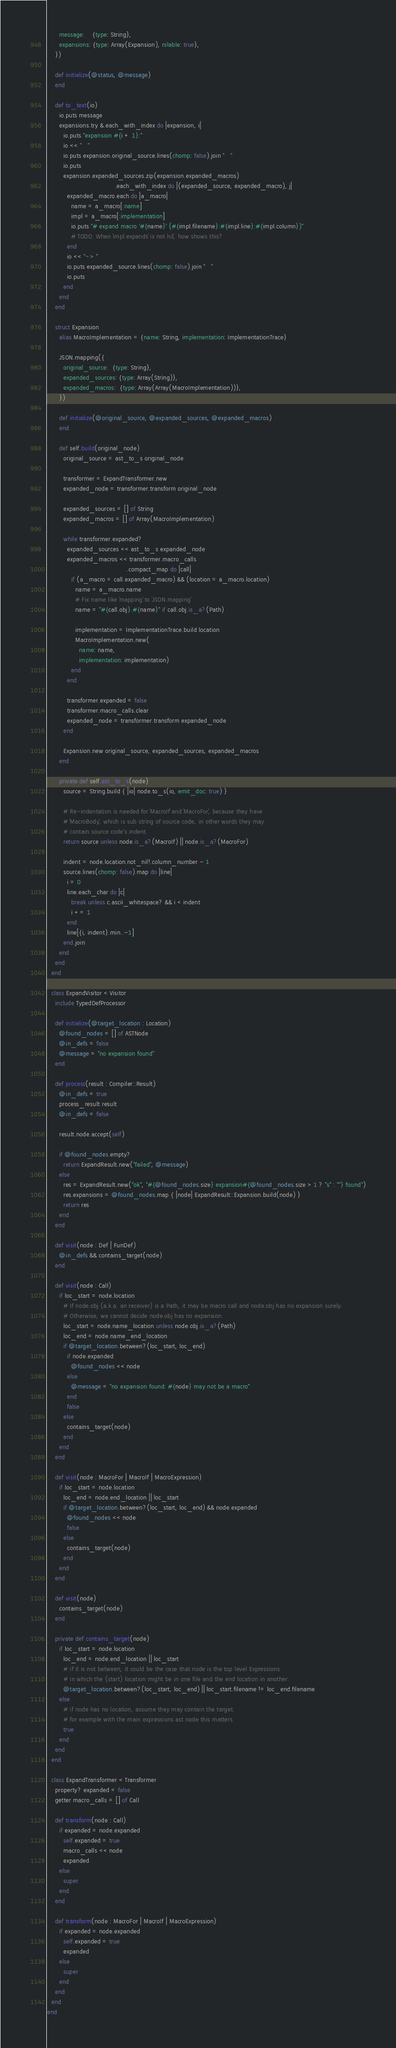<code> <loc_0><loc_0><loc_500><loc_500><_Crystal_>      message:    {type: String},
      expansions: {type: Array(Expansion), nilable: true},
    })

    def initialize(@status, @message)
    end

    def to_text(io)
      io.puts message
      expansions.try &.each_with_index do |expansion, i|
        io.puts "expansion #{i + 1}:"
        io << "   "
        io.puts expansion.original_source.lines(chomp: false).join "   "
        io.puts
        expansion.expanded_sources.zip(expansion.expanded_macros)
                                  .each_with_index do |(expanded_source, expanded_macro), j|
          expanded_macro.each do |a_macro|
            name = a_macro[:name]
            impl = a_macro[:implementation]
            io.puts "# expand macro '#{name}' (#{impl.filename}:#{impl.line}:#{impl.column})"
            # TODO: When `impl.expands` is not `nil`, how shows this?
          end
          io << "~> "
          io.puts expanded_source.lines(chomp: false).join "   "
          io.puts
        end
      end
    end

    struct Expansion
      alias MacroImplementation = {name: String, implementation: ImplementationTrace}

      JSON.mapping({
        original_source:  {type: String},
        expanded_sources: {type: Array(String)},
        expanded_macros:  {type: Array(Array(MacroImplementation))},
      })

      def initialize(@original_source, @expanded_sources, @expanded_macros)
      end

      def self.build(original_node)
        original_source = ast_to_s original_node

        transformer = ExpandTransformer.new
        expanded_node = transformer.transform original_node

        expanded_sources = [] of String
        expanded_macros = [] of Array(MacroImplementation)

        while transformer.expanded?
          expanded_sources << ast_to_s expanded_node
          expanded_macros << transformer.macro_calls
                                        .compact_map do |call|
            if (a_macro = call.expanded_macro) && (location = a_macro.location)
              name = a_macro.name
              # Fix name like `mapping` to `JSON.mapping`
              name = "#{call.obj}.#{name}" if call.obj.is_a?(Path)

              implementation = ImplementationTrace.build location
              MacroImplementation.new(
                name: name,
                implementation: implementation)
            end
          end

          transformer.expanded = false
          transformer.macro_calls.clear
          expanded_node = transformer.transform expanded_node
        end

        Expansion.new original_source, expanded_sources, expanded_macros
      end

      private def self.ast_to_s(node)
        source = String.build { |io| node.to_s(io, emit_doc: true) }

        # Re-indentation is needed for `MacroIf` and `MacroFor`, because they have
        # `MacroBody`, which is sub string of source code, in other words they may
        # contain source code's indent.
        return source unless node.is_a?(MacroIf) || node.is_a?(MacroFor)

        indent = node.location.not_nil!.column_number - 1
        source.lines(chomp: false).map do |line|
          i = 0
          line.each_char do |c|
            break unless c.ascii_whitespace? && i < indent
            i += 1
          end
          line[{i, indent}.min..-1]
        end.join
      end
    end
  end

  class ExpandVisitor < Visitor
    include TypedDefProcessor

    def initialize(@target_location : Location)
      @found_nodes = [] of ASTNode
      @in_defs = false
      @message = "no expansion found"
    end

    def process(result : Compiler::Result)
      @in_defs = true
      process_result result
      @in_defs = false

      result.node.accept(self)

      if @found_nodes.empty?
        return ExpandResult.new("failed", @message)
      else
        res = ExpandResult.new("ok", "#{@found_nodes.size} expansion#{@found_nodes.size > 1 ? "s" : ""} found")
        res.expansions = @found_nodes.map { |node| ExpandResult::Expansion.build(node) }
        return res
      end
    end

    def visit(node : Def | FunDef)
      @in_defs && contains_target(node)
    end

    def visit(node : Call)
      if loc_start = node.location
        # If node.obj (a.k.a. an receiver) is a Path, it may be macro call and node.obj has no expansion surely.
        # Otherwise, we cannot decide node.obj has no expansion.
        loc_start = node.name_location unless node.obj.is_a?(Path)
        loc_end = node.name_end_location
        if @target_location.between?(loc_start, loc_end)
          if node.expanded
            @found_nodes << node
          else
            @message = "no expansion found: #{node} may not be a macro"
          end
          false
        else
          contains_target(node)
        end
      end
    end

    def visit(node : MacroFor | MacroIf | MacroExpression)
      if loc_start = node.location
        loc_end = node.end_location || loc_start
        if @target_location.between?(loc_start, loc_end) && node.expanded
          @found_nodes << node
          false
        else
          contains_target(node)
        end
      end
    end

    def visit(node)
      contains_target(node)
    end

    private def contains_target(node)
      if loc_start = node.location
        loc_end = node.end_location || loc_start
        # if it is not between, it could be the case that node is the top level Expressions
        # in which the (start) location might be in one file and the end location in another.
        @target_location.between?(loc_start, loc_end) || loc_start.filename != loc_end.filename
      else
        # if node has no location, assume they may contain the target.
        # for example with the main expressions ast node this matters
        true
      end
    end
  end

  class ExpandTransformer < Transformer
    property? expanded = false
    getter macro_calls = [] of Call

    def transform(node : Call)
      if expanded = node.expanded
        self.expanded = true
        macro_calls << node
        expanded
      else
        super
      end
    end

    def transform(node : MacroFor | MacroIf | MacroExpression)
      if expanded = node.expanded
        self.expanded = true
        expanded
      else
        super
      end
    end
  end
end
</code> 